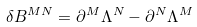<formula> <loc_0><loc_0><loc_500><loc_500>\delta B ^ { M N } = \partial ^ { M } \Lambda ^ { N } - \partial ^ { N } \Lambda ^ { M }</formula> 